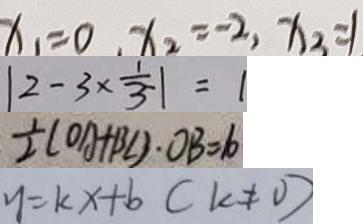Convert formula to latex. <formula><loc_0><loc_0><loc_500><loc_500>x _ { 1 } = 0 , x _ { 2 } = - 2 , x _ { 2 } = 1 
 \vert 2 - 3 \times \frac { 1 } { 3 } \vert = 1 
 \frac { 1 } { 2 } ( O A + B C ) \cdot O B = 6 
 y = k x + b ( k \neq 0 )</formula> 